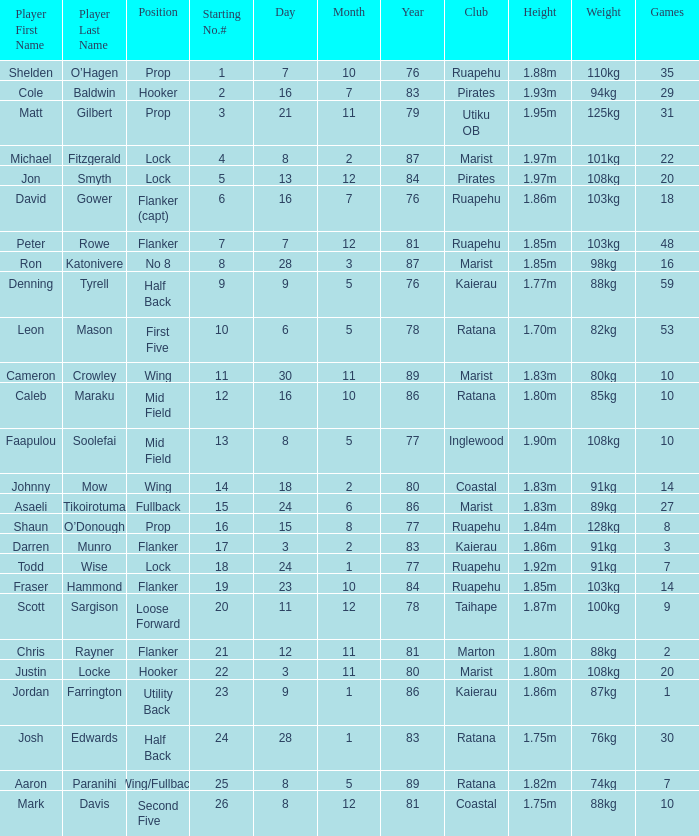Which participant weighs 76kg? Josh Edwards. Would you be able to parse every entry in this table? {'header': ['Player First Name', 'Player Last Name', 'Position', 'Starting No.#', 'Day', 'Month', 'Year', 'Club', 'Height', 'Weight', 'Games'], 'rows': [['Shelden', 'O’Hagen', 'Prop', '1', '7', '10', '76', 'Ruapehu', '1.88m', '110kg', '35'], ['Cole', 'Baldwin', 'Hooker', '2', '16', '7', '83', 'Pirates', '1.93m', '94kg', '29'], ['Matt', 'Gilbert', 'Prop', '3', '21', '11', '79', 'Utiku OB', '1.95m', '125kg', '31'], ['Michael', 'Fitzgerald', 'Lock', '4', '8', '2', '87', 'Marist', '1.97m', '101kg', '22'], ['Jon', 'Smyth', 'Lock', '5', '13', '12', '84', 'Pirates', '1.97m', '108kg', '20'], ['David', 'Gower', 'Flanker (capt)', '6', '16', '7', '76', 'Ruapehu', '1.86m', '103kg', '18'], ['Peter', 'Rowe', 'Flanker', '7', '7', '12', '81', 'Ruapehu', '1.85m', '103kg', '48'], ['Ron', 'Katonivere', 'No 8', '8', '28', '3', '87', 'Marist', '1.85m', '98kg', '16'], ['Denning', 'Tyrell', 'Half Back', '9', '9', '5', '76', 'Kaierau', '1.77m', '88kg', '59'], ['Leon', 'Mason', 'First Five', '10', '6', '5', '78', 'Ratana', '1.70m', '82kg', '53'], ['Cameron', 'Crowley', 'Wing', '11', '30', '11', '89', 'Marist', '1.83m', '80kg', '10'], ['Caleb', 'Maraku', 'Mid Field', '12', '16', '10', '86', 'Ratana', '1.80m', '85kg', '10'], ['Faapulou', 'Soolefai', 'Mid Field', '13', '8', '5', '77', 'Inglewood', '1.90m', '108kg', '10'], ['Johnny', 'Mow', 'Wing', '14', '18', '2', '80', 'Coastal', '1.83m', '91kg', '14'], ['Asaeli', 'Tikoirotuma', 'Fullback', '15', '24', '6', '86', 'Marist', '1.83m', '89kg', '27'], ['Shaun', 'O’Donough', 'Prop', '16', '15', '8', '77', 'Ruapehu', '1.84m', '128kg', '8'], ['Darren', 'Munro', 'Flanker', '17', '3', '2', '83', 'Kaierau', '1.86m', '91kg', '3'], ['Todd', 'Wise', 'Lock', '18', '24', '1', '77', 'Ruapehu', '1.92m', '91kg', '7'], ['Fraser', 'Hammond', 'Flanker', '19', '23', '10', '84', 'Ruapehu', '1.85m', '103kg', '14'], ['Scott', 'Sargison', 'Loose Forward', '20', '11', '12', '78', 'Taihape', '1.87m', '100kg', '9'], ['Chris', 'Rayner', 'Flanker', '21', '12', '11', '81', 'Marton', '1.80m', '88kg', '2'], ['Justin', 'Locke', 'Hooker', '22', '3', '11', '80', 'Marist', '1.80m', '108kg', '20'], ['Jordan', 'Farrington', 'Utility Back', '23', '9', '1', '86', 'Kaierau', '1.86m', '87kg', '1'], ['Josh', 'Edwards', 'Half Back', '24', '28', '1', '83', 'Ratana', '1.75m', '76kg', '30'], ['Aaron', 'Paranihi', 'Wing/Fullback', '25', '8', '5', '89', 'Ratana', '1.82m', '74kg', '7'], ['Mark', 'Davis', 'Second Five', '26', '8', '12', '81', 'Coastal', '1.75m', '88kg', '10']]} 